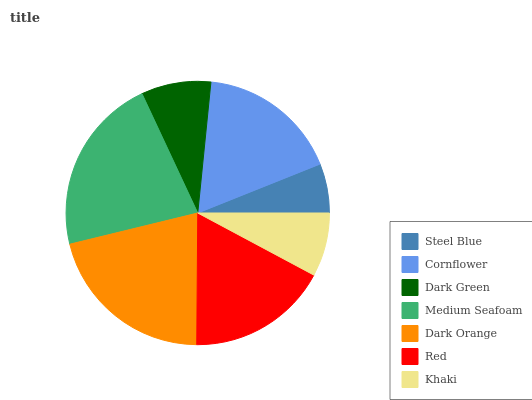Is Steel Blue the minimum?
Answer yes or no. Yes. Is Medium Seafoam the maximum?
Answer yes or no. Yes. Is Cornflower the minimum?
Answer yes or no. No. Is Cornflower the maximum?
Answer yes or no. No. Is Cornflower greater than Steel Blue?
Answer yes or no. Yes. Is Steel Blue less than Cornflower?
Answer yes or no. Yes. Is Steel Blue greater than Cornflower?
Answer yes or no. No. Is Cornflower less than Steel Blue?
Answer yes or no. No. Is Red the high median?
Answer yes or no. Yes. Is Red the low median?
Answer yes or no. Yes. Is Dark Green the high median?
Answer yes or no. No. Is Medium Seafoam the low median?
Answer yes or no. No. 